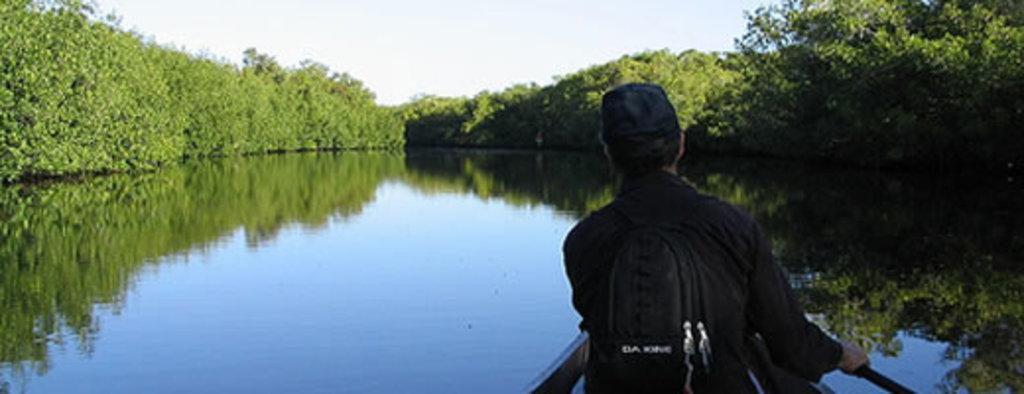What is the main subject of the image? There is a person in the image. What is the person wearing? The person is wearing a black dress. What else is the person carrying? The person is carrying a black bag on their back. Where is the person located in the image? The person is sitting in a boat. What is the boat's location in the image? The boat is on the water. What can be seen in the background of the image? There are trees on either side of the person. What type of war is being fought in the image? There is no war present in the image; it features a person sitting in a boat on the water. What arm is the person using to paddle the boat? The image does not show the person paddling the boat, nor does it show any arms. 